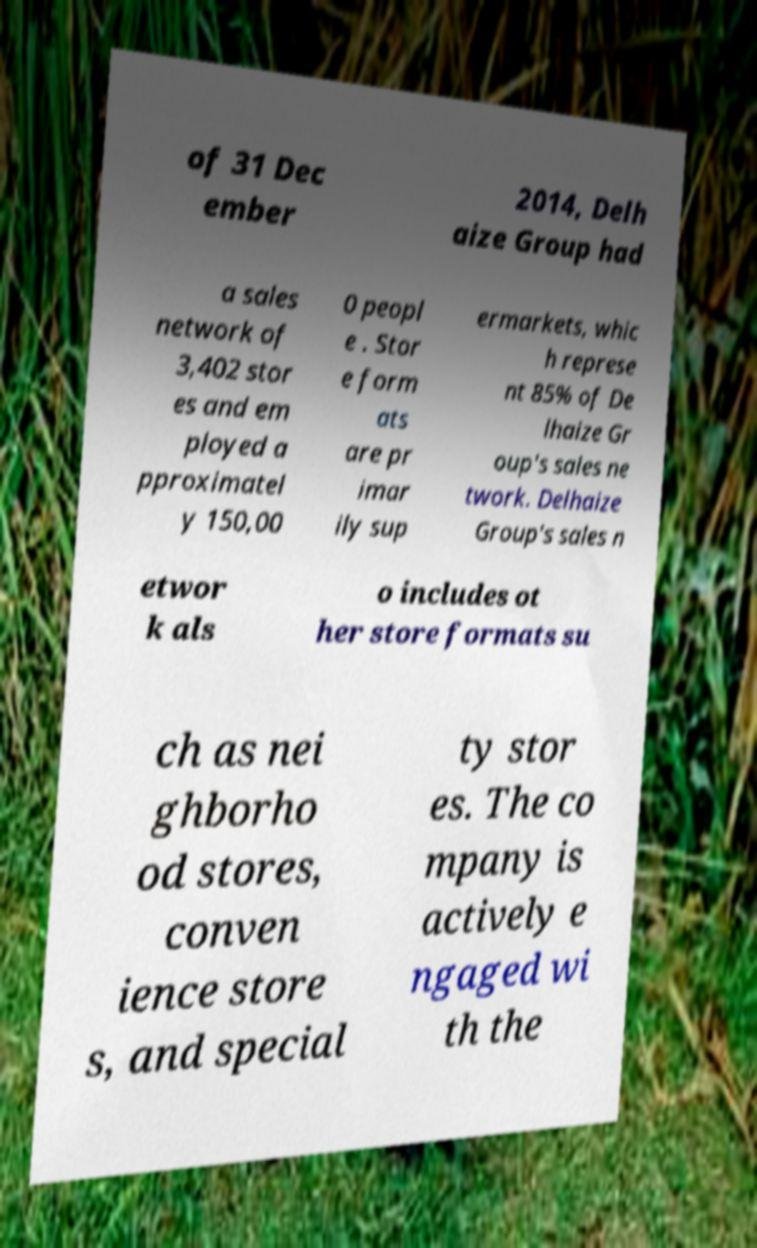Can you accurately transcribe the text from the provided image for me? of 31 Dec ember 2014, Delh aize Group had a sales network of 3,402 stor es and em ployed a pproximatel y 150,00 0 peopl e . Stor e form ats are pr imar ily sup ermarkets, whic h represe nt 85% of De lhaize Gr oup's sales ne twork. Delhaize Group's sales n etwor k als o includes ot her store formats su ch as nei ghborho od stores, conven ience store s, and special ty stor es. The co mpany is actively e ngaged wi th the 